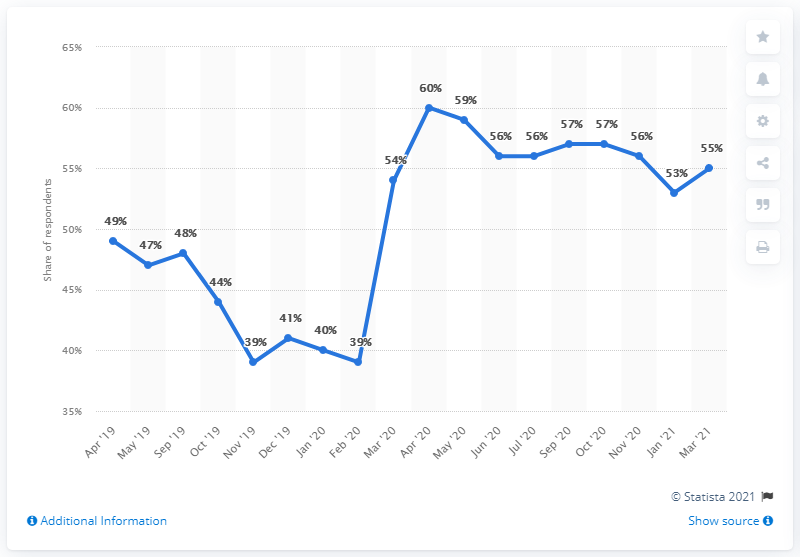Highlight a few significant elements in this photo. The April 2020 period has the highest percentage among the three periods. For how many periods was the value above 55%? In March 2021, a majority of respondents, approximately 55%, trusted Giuseppe Conte. 